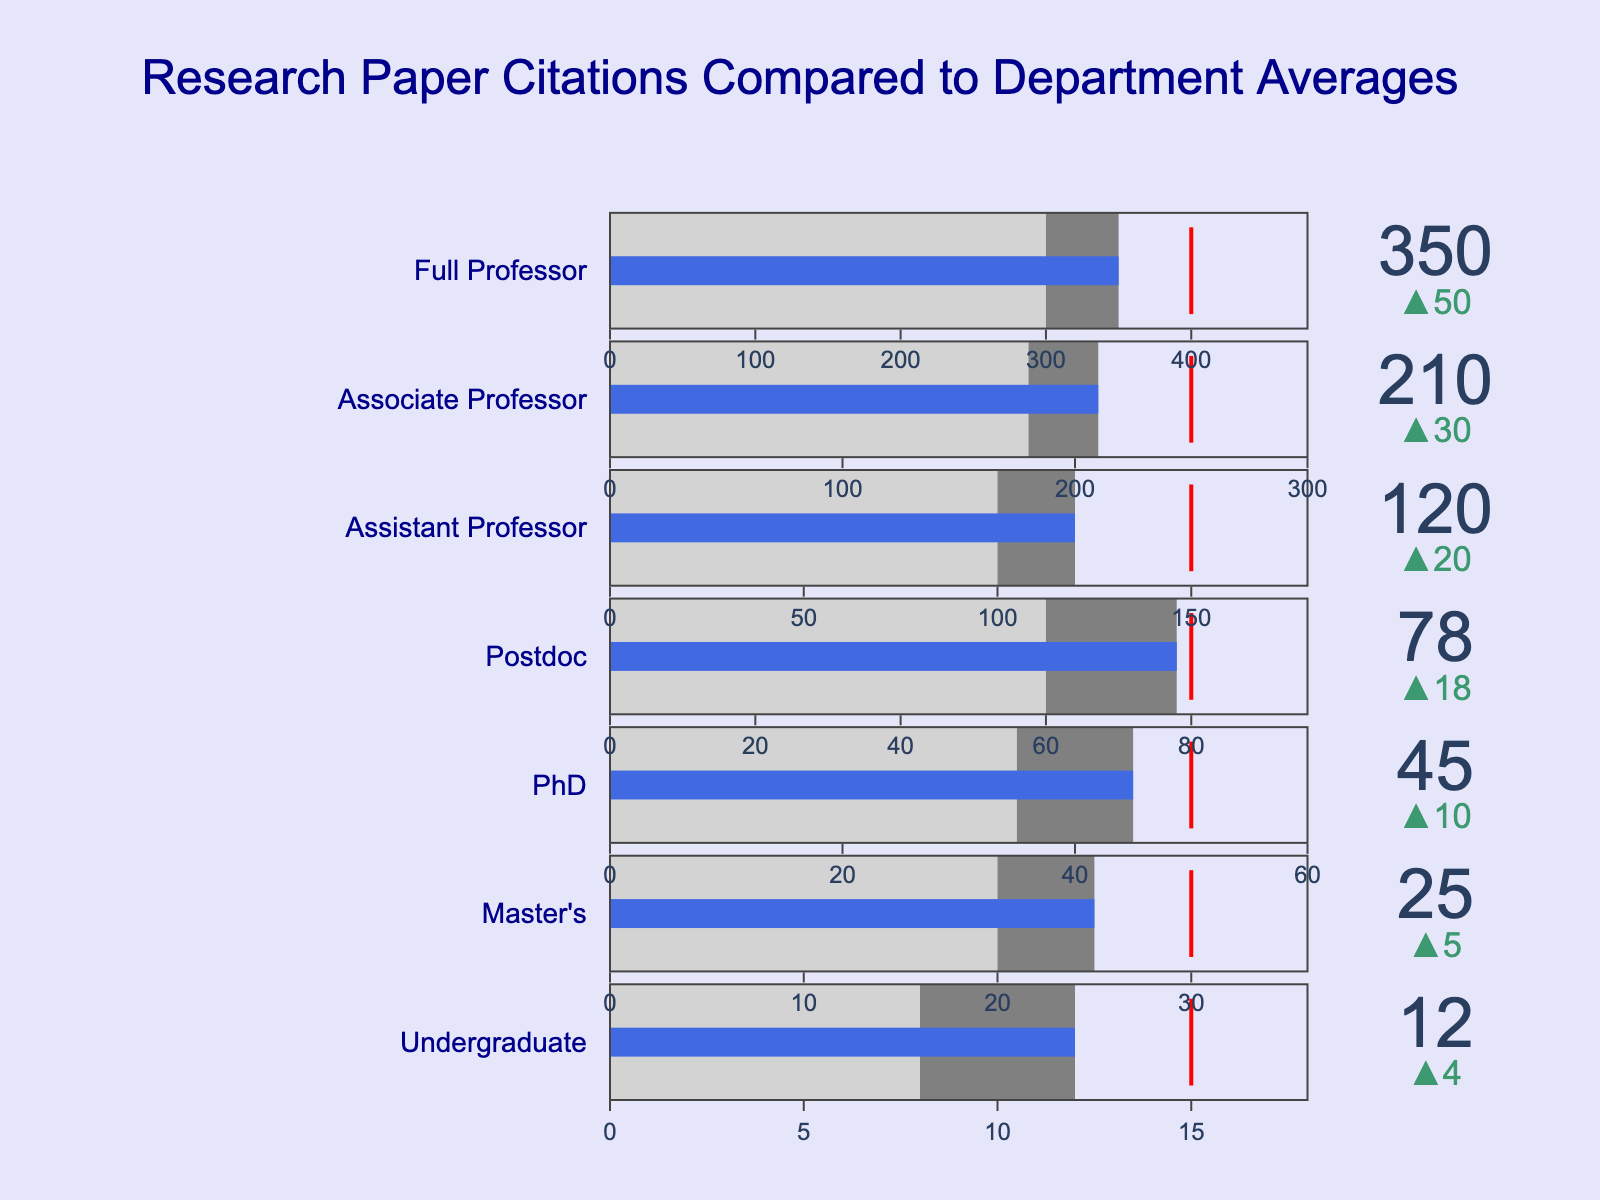What's the title of the figure? The title is often placed at the top of the figure and in this case, it is stated in the `update_layout` method.
Answer: Research Paper Citations Compared to Department Averages How many academic levels are displayed in the figure? Each unique `Category` in the data corresponds to an academic level. Counting them, we get 7.
Answer: 7 What's the actual number of citations for the "Associate Professor" category? The actual number is displayed directly on the bullet chart for each category. For "Associate Professor," it is given as 210.
Answer: 210 Which category has the smallest difference between the actual and target citations? By calculating the differences for all categories: Undergraduate (15-12=3), Master's (30-25=5), PhD (50-45=5), Postdoc (80-78=2), Assistant Professor (150-120=30), Associate Professor (250-210=40), Full Professor (400-350=50). The smallest difference is for Postdoc.
Answer: Postdoc Are there any categories where the actual citations meet or exceed the target? We compare the actual and target citations for each category. Only the "Full Professor" (350 actual vs 400 target) meets or exceeds their target.
Answer: No Which category shows the largest discrepancy between actual and comparative citations? By calculating the differences for all categories: Undergraduate (12-8=4), Master's (25-20=5), PhD (45-35=10), Postdoc (78-60=18), Assistant Professor (120-100=20), Associate Professor (210-180=30), Full Professor (350-300=50). The largest discrepancy is in Full Professor.
Answer: Full Professor What color represents the steps between comparative and actual citations? The color for the steps between comparative and actual is given in the `steps` attribute and is "gray".
Answer: Gray How much higher is the actual number of citations for "Assistant Professor" compared to "Master's"? The actual number for Assistant Professor is 120 and for Master's is 25. So, the difference is 120 - 25 = 95.
Answer: 95 What does the red line in each bullet chart indicate? The red line represents the target value for each category as specified in the `threshold` attribute.
Answer: Target value Which academic level is closest to their target citation goal? We need to find the category where the difference between actual citations and target citations is the smallest. This is the "Postdoc" category with a difference of 2 (80 - 78 = 2).
Answer: Postdoc 